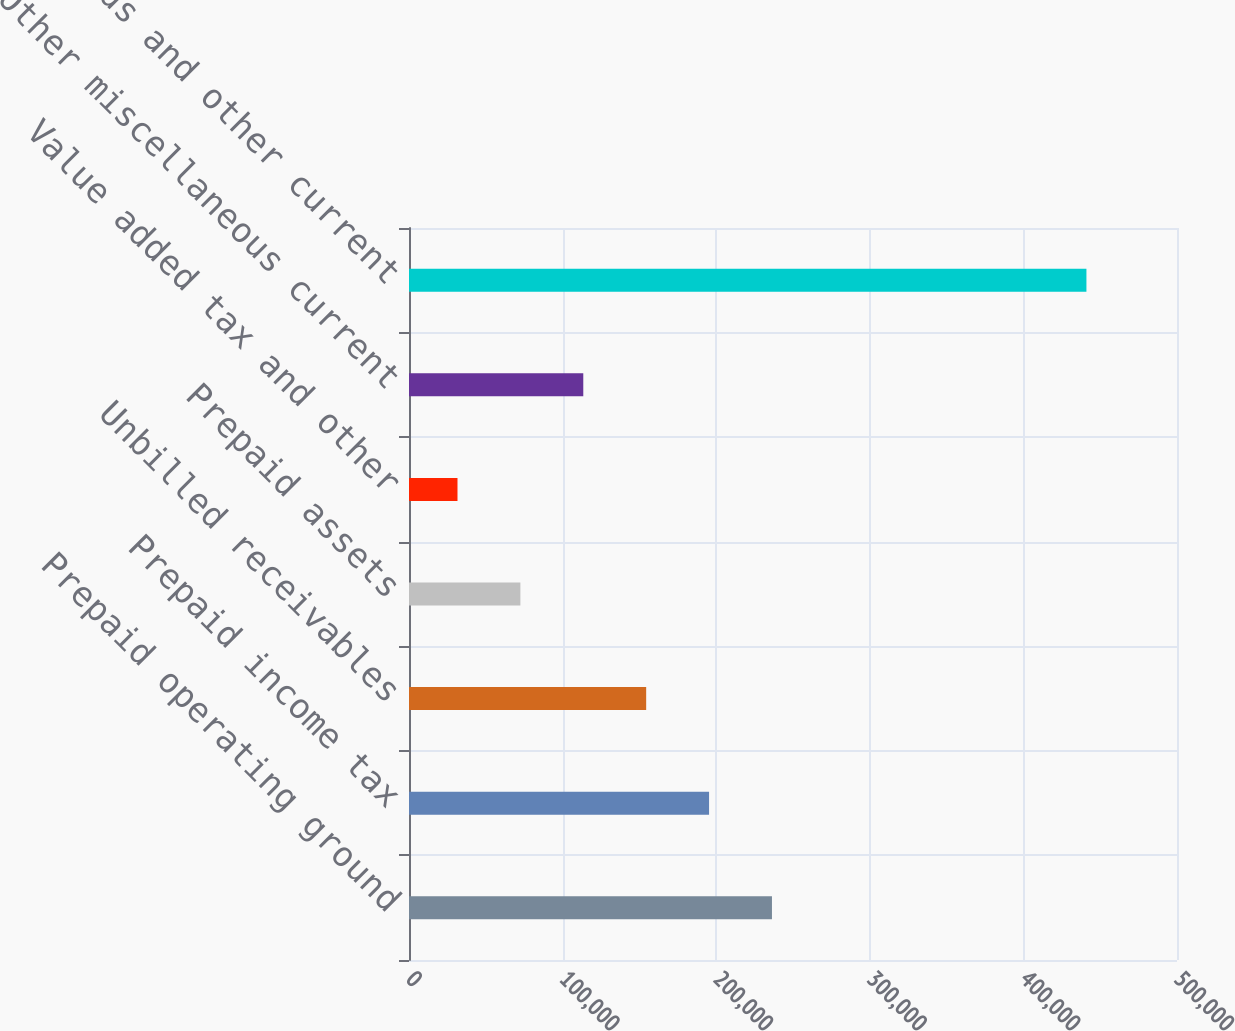Convert chart. <chart><loc_0><loc_0><loc_500><loc_500><bar_chart><fcel>Prepaid operating ground<fcel>Prepaid income tax<fcel>Unbilled receivables<fcel>Prepaid assets<fcel>Value added tax and other<fcel>Other miscellaneous current<fcel>Prepaids and other current<nl><fcel>236302<fcel>195355<fcel>154409<fcel>72516.3<fcel>31570<fcel>113463<fcel>441033<nl></chart> 